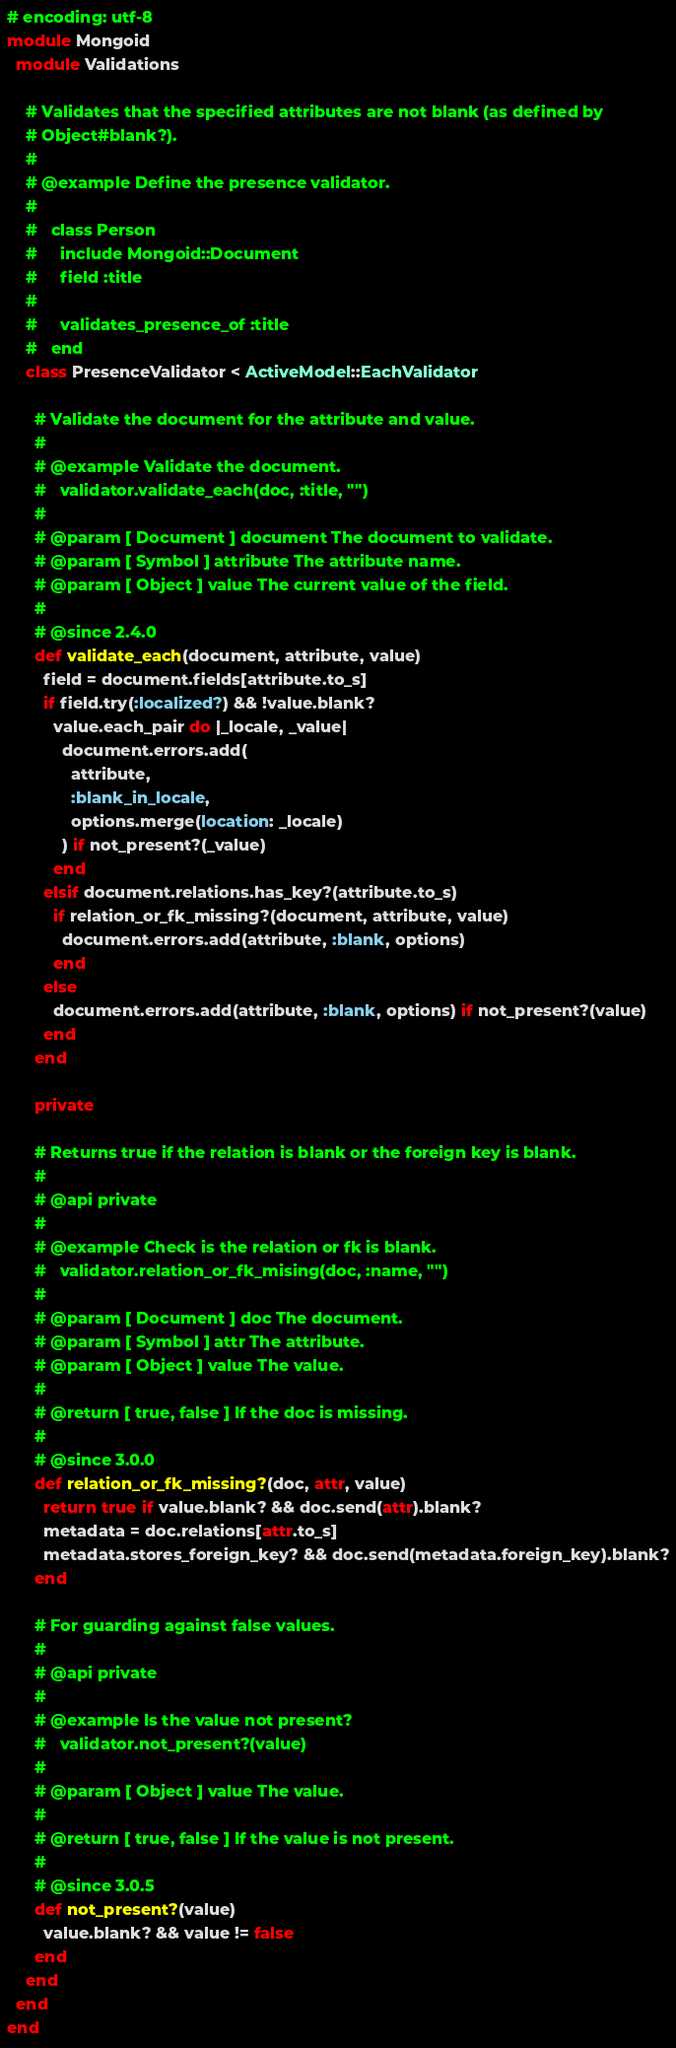<code> <loc_0><loc_0><loc_500><loc_500><_Ruby_># encoding: utf-8
module Mongoid
  module Validations

    # Validates that the specified attributes are not blank (as defined by
    # Object#blank?).
    #
    # @example Define the presence validator.
    #
    #   class Person
    #     include Mongoid::Document
    #     field :title
    #
    #     validates_presence_of :title
    #   end
    class PresenceValidator < ActiveModel::EachValidator

      # Validate the document for the attribute and value.
      #
      # @example Validate the document.
      #   validator.validate_each(doc, :title, "")
      #
      # @param [ Document ] document The document to validate.
      # @param [ Symbol ] attribute The attribute name.
      # @param [ Object ] value The current value of the field.
      #
      # @since 2.4.0
      def validate_each(document, attribute, value)
        field = document.fields[attribute.to_s]
        if field.try(:localized?) && !value.blank?
          value.each_pair do |_locale, _value|
            document.errors.add(
              attribute,
              :blank_in_locale,
              options.merge(location: _locale)
            ) if not_present?(_value)
          end
        elsif document.relations.has_key?(attribute.to_s)
          if relation_or_fk_missing?(document, attribute, value)
            document.errors.add(attribute, :blank, options)
          end
        else
          document.errors.add(attribute, :blank, options) if not_present?(value)
        end
      end

      private

      # Returns true if the relation is blank or the foreign key is blank.
      #
      # @api private
      #
      # @example Check is the relation or fk is blank.
      #   validator.relation_or_fk_mising(doc, :name, "")
      #
      # @param [ Document ] doc The document.
      # @param [ Symbol ] attr The attribute.
      # @param [ Object ] value The value.
      #
      # @return [ true, false ] If the doc is missing.
      #
      # @since 3.0.0
      def relation_or_fk_missing?(doc, attr, value)
        return true if value.blank? && doc.send(attr).blank?
        metadata = doc.relations[attr.to_s]
        metadata.stores_foreign_key? && doc.send(metadata.foreign_key).blank?
      end

      # For guarding against false values.
      #
      # @api private
      #
      # @example Is the value not present?
      #   validator.not_present?(value)
      #
      # @param [ Object ] value The value.
      #
      # @return [ true, false ] If the value is not present.
      #
      # @since 3.0.5
      def not_present?(value)
        value.blank? && value != false
      end
    end
  end
end
</code> 